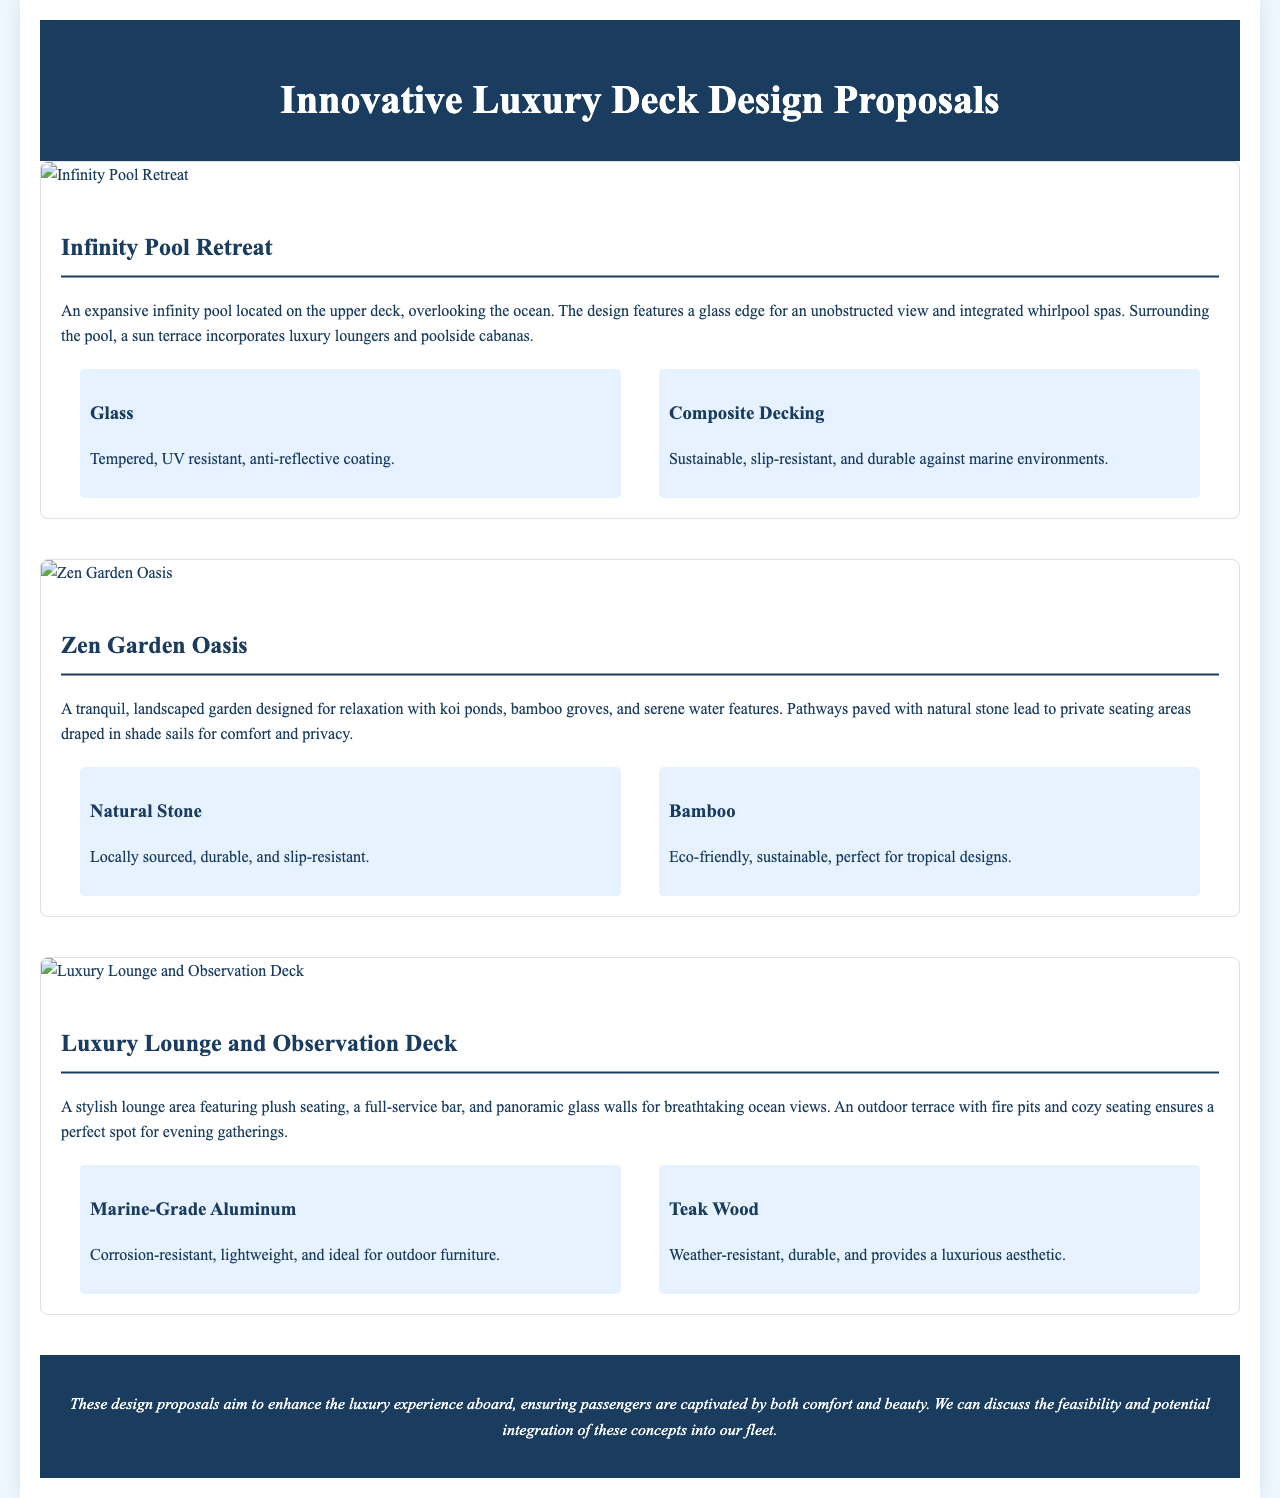What is the title of the document? The title of the document is prominently displayed at the top and states the main topic.
Answer: Innovative Luxury Deck Design Proposals How many design proposals are featured? The document lists three distinct design proposals as individual sections.
Answer: Three What are the two materials used in the Infinity Pool Retreat design? Each design proposal includes a section detailing materials used; in this case, two are specified.
Answer: Glass, Composite Decking What is the main feature of the Zen Garden Oasis? The design description highlights the main attribute that sets this proposal apart from others.
Answer: Tranquil landscaped garden What type of wood is featured in the Luxury Lounge and Observation Deck? This material is mentioned in the context of providing an aesthetic, showing it’s a luxury choice for furniture.
Answer: Teak Wood Which design includes a whirlpool spa? The proposal descriptions provide insights into the unique features; this design is specifically noted for this element.
Answer: Infinity Pool Retreat What is the main benefit of the materials used in the Natural Stone for Zen Garden Oasis? The document provides an explanation of the materials' properties, emphasizing their suitability.
Answer: Durable and slip-resistant What type of environment does the Composite Decking resist? This material's properties are described in relation to its performance in a specific setting.
Answer: Marine environments What specific feature does the outdoor terrace of the Luxury Lounge include? The proposal lists features that enhance experience; this particularly involves cozy settings for gatherings.
Answer: Fire pits 